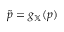<formula> <loc_0><loc_0><loc_500><loc_500>\tilde { p } = g _ { \mathbb { X } } ( p )</formula> 